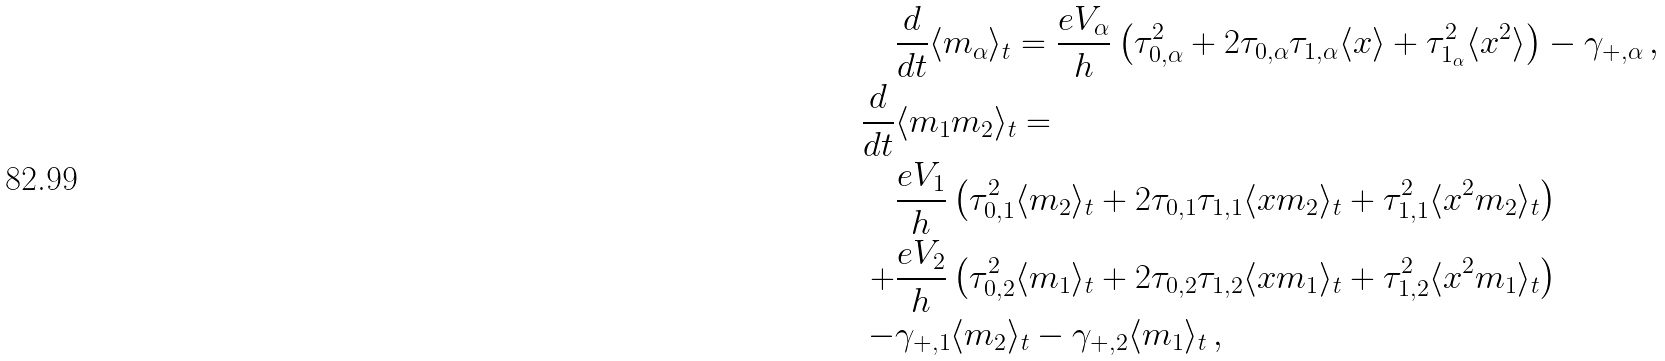<formula> <loc_0><loc_0><loc_500><loc_500>& \frac { d } { d t } \langle m _ { \alpha } \rangle _ { t } = \frac { e V _ { \alpha } } { h } \left ( \tau _ { 0 , \alpha } ^ { 2 } + 2 \tau _ { 0 , \alpha } \tau _ { 1 , \alpha } \langle x \rangle + \tau _ { 1 _ { \alpha } } ^ { 2 } \langle x ^ { 2 } \rangle \right ) - \gamma _ { + , \alpha } \, , \\ \frac { d } { d t } & \langle m _ { 1 } m _ { 2 } \rangle _ { t } = \\ & \frac { e V _ { 1 } } { h } \left ( \tau _ { 0 , 1 } ^ { 2 } \langle m _ { 2 } \rangle _ { t } + 2 \tau _ { 0 , 1 } \tau _ { 1 , 1 } \langle x m _ { 2 } \rangle _ { t } + \tau _ { 1 , 1 } ^ { 2 } \langle x ^ { 2 } m _ { 2 } \rangle _ { t } \right ) \\ + & \frac { e V _ { 2 } } { h } \left ( \tau _ { 0 , 2 } ^ { 2 } \langle m _ { 1 } \rangle _ { t } + 2 \tau _ { 0 , 2 } \tau _ { 1 , 2 } \langle x m _ { 1 } \rangle _ { t } + \tau _ { 1 , 2 } ^ { 2 } \langle x ^ { 2 } m _ { 1 } \rangle _ { t } \right ) \\ - & \gamma _ { + , 1 } \langle m _ { 2 } \rangle _ { t } - \gamma _ { + , 2 } \langle m _ { 1 } \rangle _ { t } \, ,</formula> 